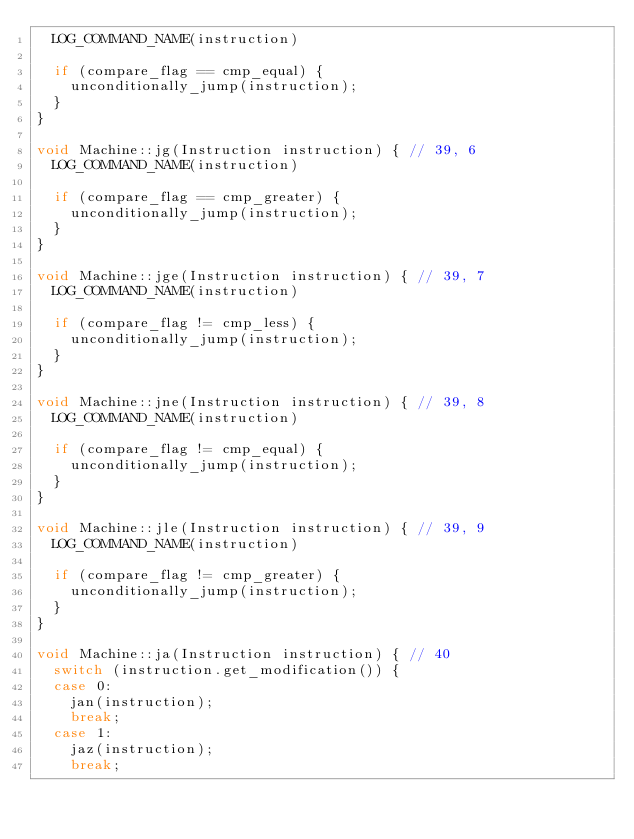Convert code to text. <code><loc_0><loc_0><loc_500><loc_500><_C++_>  LOG_COMMAND_NAME(instruction)

  if (compare_flag == cmp_equal) {
    unconditionally_jump(instruction);
  }
}

void Machine::jg(Instruction instruction) { // 39, 6
  LOG_COMMAND_NAME(instruction)

  if (compare_flag == cmp_greater) {
    unconditionally_jump(instruction);
  }
}

void Machine::jge(Instruction instruction) { // 39, 7
  LOG_COMMAND_NAME(instruction)

  if (compare_flag != cmp_less) {
    unconditionally_jump(instruction);
  }
}

void Machine::jne(Instruction instruction) { // 39, 8
  LOG_COMMAND_NAME(instruction)

  if (compare_flag != cmp_equal) {
    unconditionally_jump(instruction);
  }
}

void Machine::jle(Instruction instruction) { // 39, 9
  LOG_COMMAND_NAME(instruction)

  if (compare_flag != cmp_greater) {
    unconditionally_jump(instruction);
  }
}

void Machine::ja(Instruction instruction) { // 40
  switch (instruction.get_modification()) {
  case 0:
    jan(instruction);
    break;
  case 1:
    jaz(instruction);
    break;</code> 